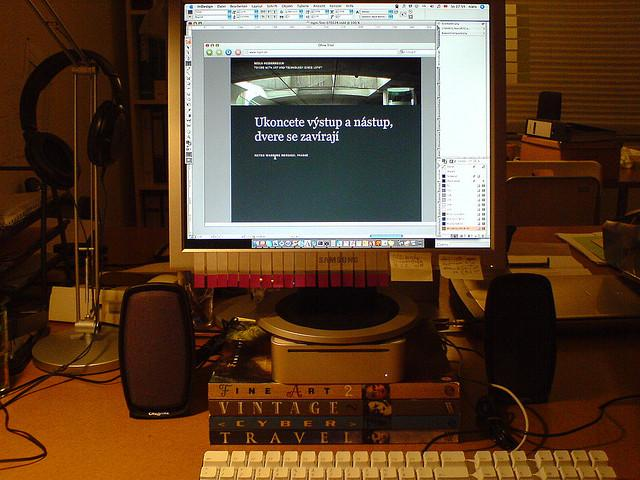What is the monitor sitting on top of above the desk?

Choices:
A) papers
B) books
C) blocks
D) stand books 